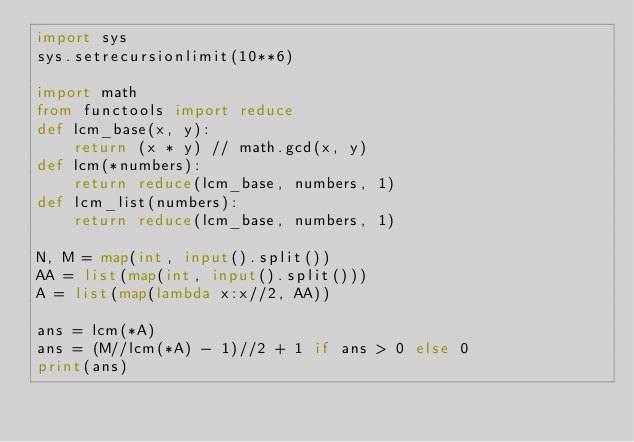Convert code to text. <code><loc_0><loc_0><loc_500><loc_500><_Python_>import sys
sys.setrecursionlimit(10**6)

import math
from functools import reduce
def lcm_base(x, y):
    return (x * y) // math.gcd(x, y)
def lcm(*numbers):
    return reduce(lcm_base, numbers, 1)
def lcm_list(numbers):
    return reduce(lcm_base, numbers, 1)

N, M = map(int, input().split())
AA = list(map(int, input().split()))
A = list(map(lambda x:x//2, AA))

ans = lcm(*A)
ans = (M//lcm(*A) - 1)//2 + 1 if ans > 0 else 0
print(ans)</code> 